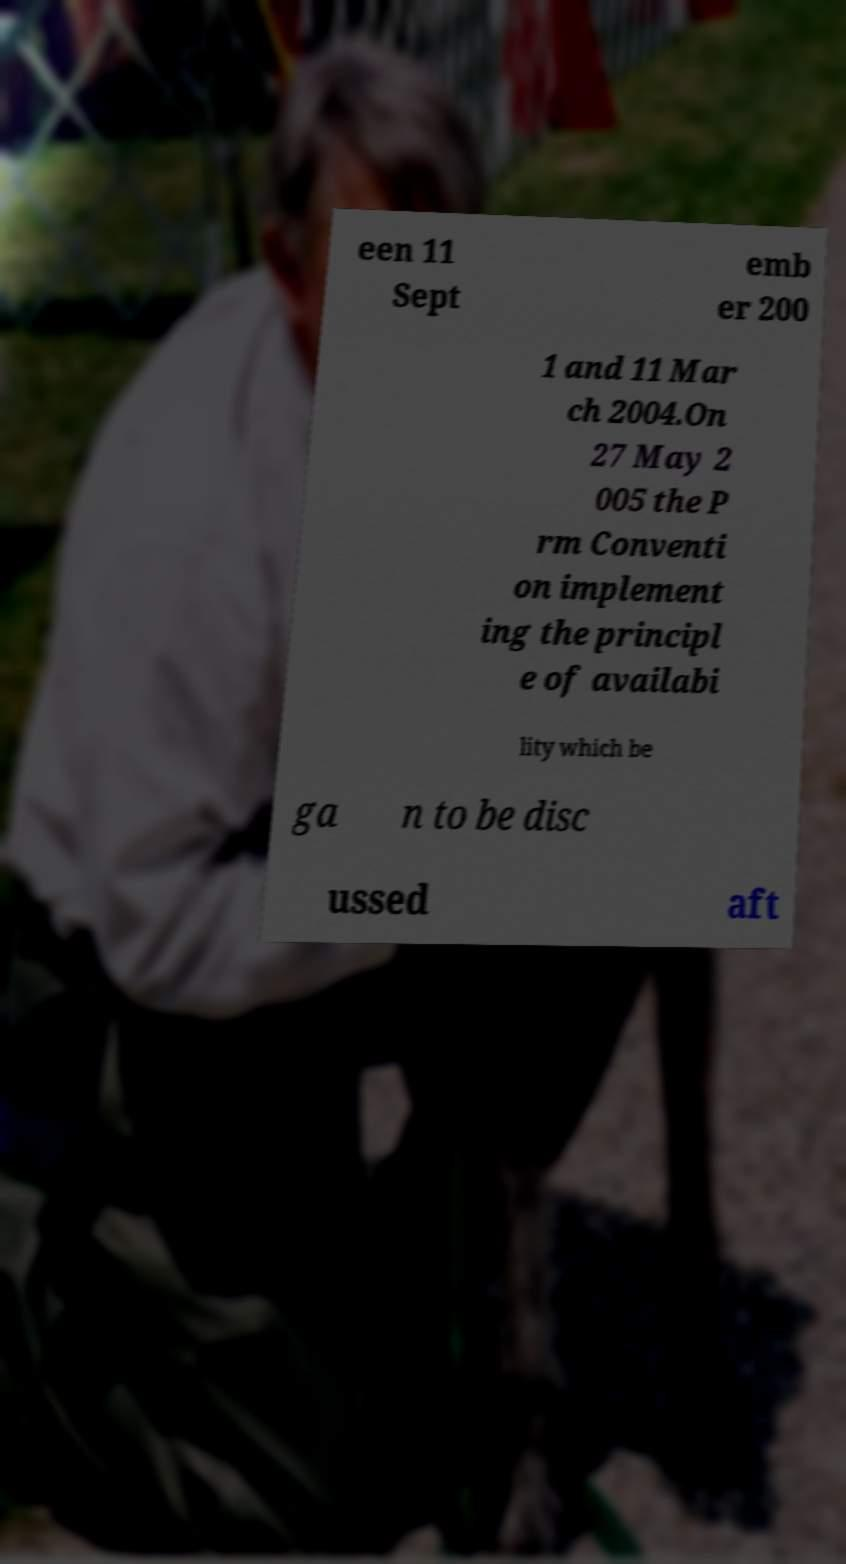Can you read and provide the text displayed in the image?This photo seems to have some interesting text. Can you extract and type it out for me? een 11 Sept emb er 200 1 and 11 Mar ch 2004.On 27 May 2 005 the P rm Conventi on implement ing the principl e of availabi lity which be ga n to be disc ussed aft 